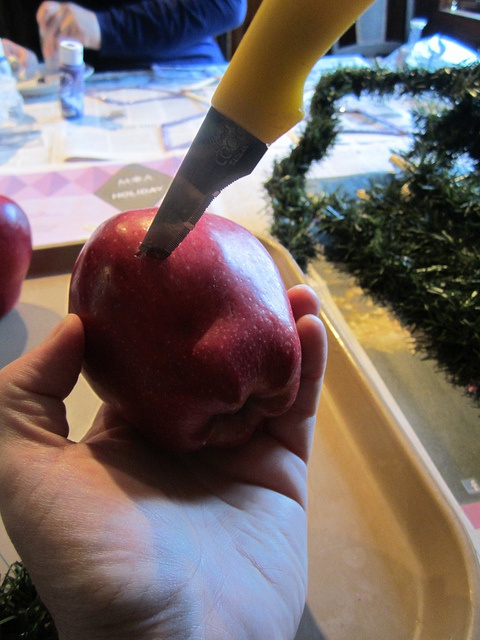Describe the objects in this image and their specific colors. I can see people in black, darkgray, and maroon tones, apple in black, maroon, lavender, and brown tones, knife in black, maroon, and olive tones, and people in black, navy, and darkgray tones in this image. 